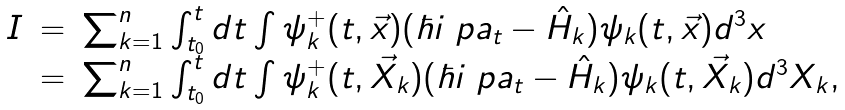<formula> <loc_0><loc_0><loc_500><loc_500>\begin{array} { l l l } { I } & = & \sum ^ { n } _ { k = 1 } \int ^ { t } _ { t _ { 0 } } d t \int \psi ^ { + } _ { k } ( t , \vec { x } ) ( \hbar { i } \ p a _ { t } - { \hat { H } _ { k } } ) \psi _ { k } ( t , \vec { x } ) d ^ { 3 } x \\ & = & \sum ^ { n } _ { k = 1 } \int ^ { t } _ { t _ { 0 } } d t \int \psi ^ { + } _ { k } ( t , \vec { X } _ { k } ) ( \hbar { i } \ p a _ { t } - { \hat { H } _ { k } } ) \psi _ { k } ( t , \vec { X } _ { k } ) d ^ { 3 } { X } _ { k } , \end{array}</formula> 